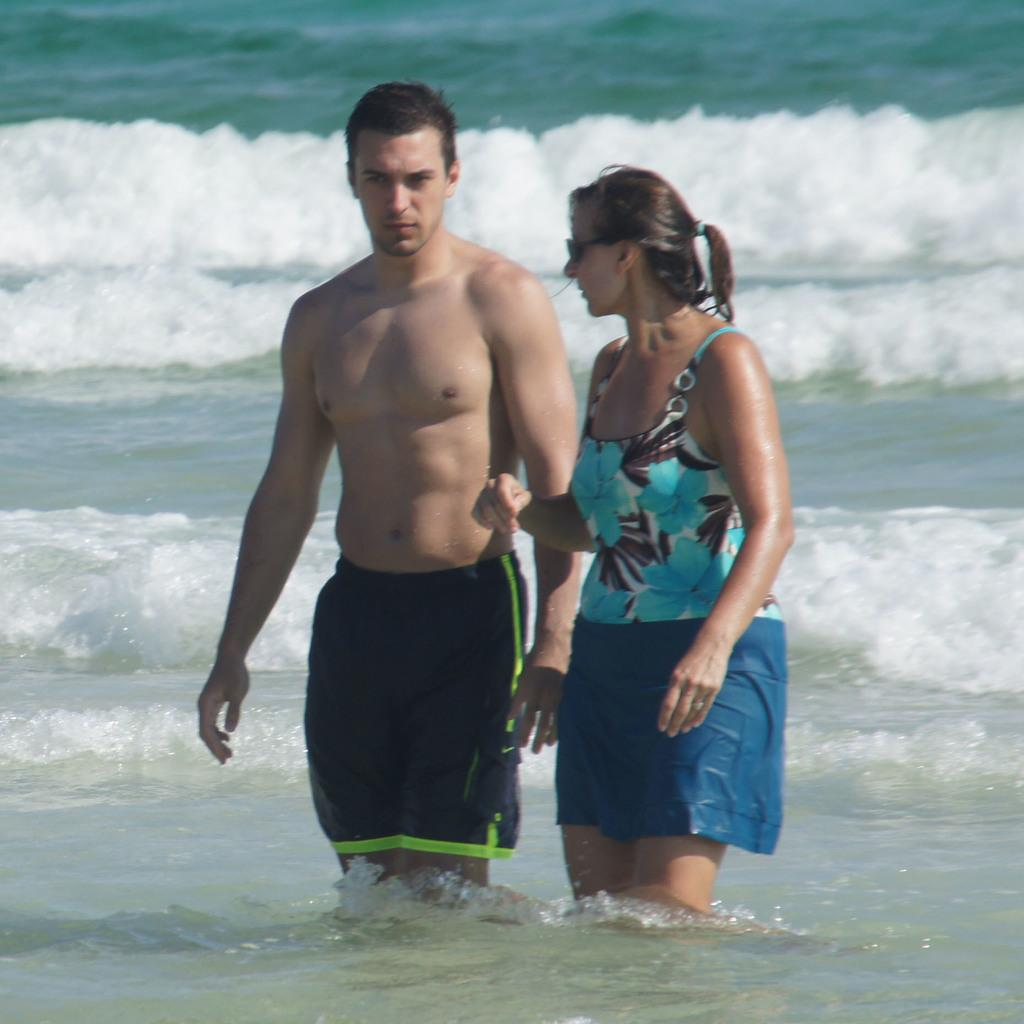How many people are in the image? There is a woman and a man in the image. Where are the woman and man located in the image? Both the woman and man are visible on the ocean in the image. What can be seen in the ocean? Tides are visible in the image. What is the woman wearing in the image? The woman is wearing a spectacle and a blue color dress in the image. What type of tent can be seen in the image? There is no tent present in the image. 